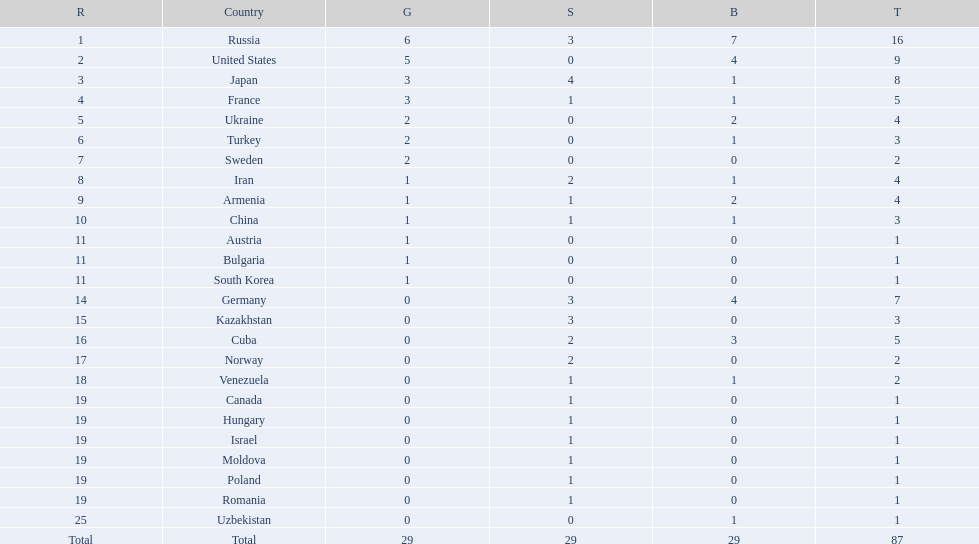What is the total amount of nations with more than 5 bronze medals? 1. 